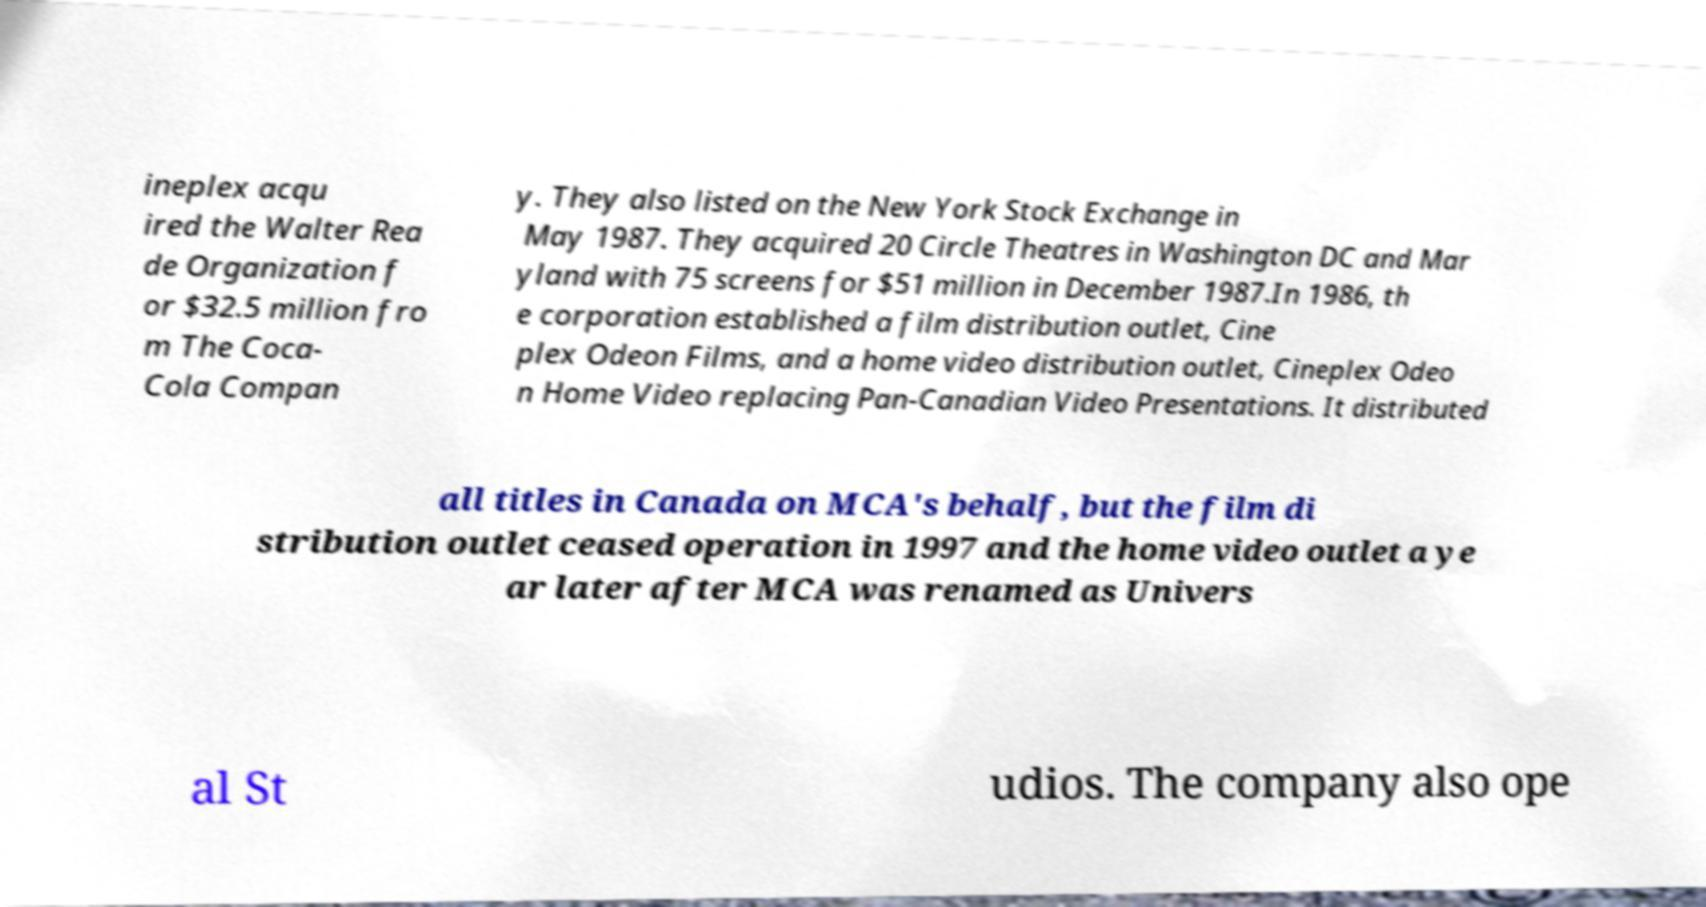Please identify and transcribe the text found in this image. ineplex acqu ired the Walter Rea de Organization f or $32.5 million fro m The Coca- Cola Compan y. They also listed on the New York Stock Exchange in May 1987. They acquired 20 Circle Theatres in Washington DC and Mar yland with 75 screens for $51 million in December 1987.In 1986, th e corporation established a film distribution outlet, Cine plex Odeon Films, and a home video distribution outlet, Cineplex Odeo n Home Video replacing Pan-Canadian Video Presentations. It distributed all titles in Canada on MCA's behalf, but the film di stribution outlet ceased operation in 1997 and the home video outlet a ye ar later after MCA was renamed as Univers al St udios. The company also ope 